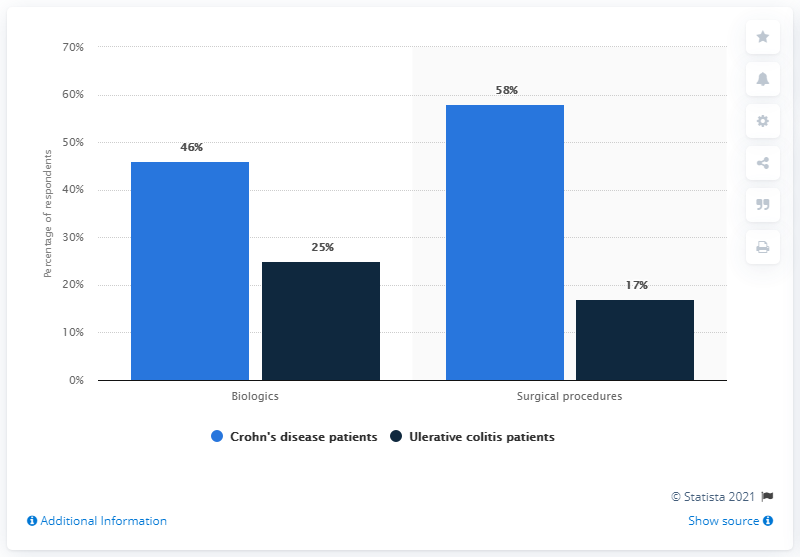Indicate a few pertinent items in this graphic. The average number of patients who received treatments in total is 36.5. The study found that patients with Crohn's disease underwent more surgical procedures than other patient types. 